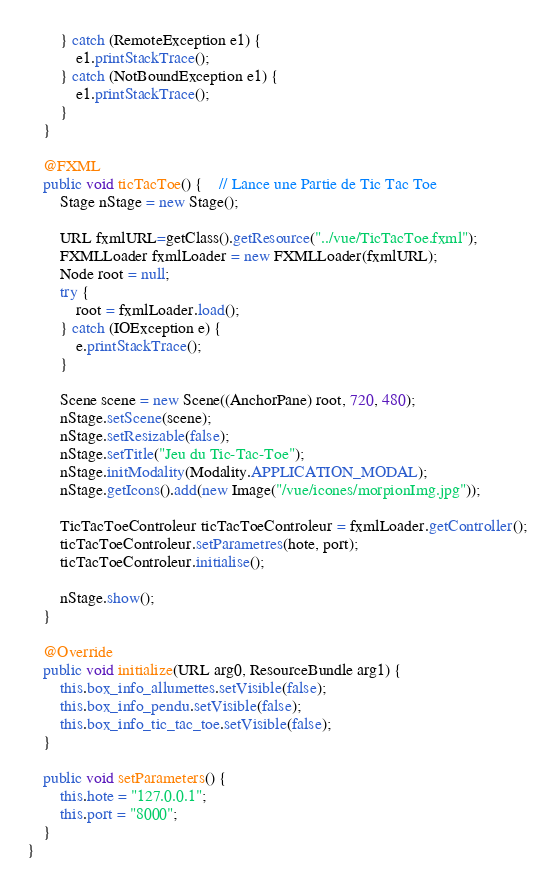<code> <loc_0><loc_0><loc_500><loc_500><_Java_>		} catch (RemoteException e1) {
			e1.printStackTrace();
		} catch (NotBoundException e1) {
			e1.printStackTrace();
		}
	}
	
	@FXML
	public void ticTacToe() {	// Lance une Partie de Tic Tac Toe
		Stage nStage = new Stage();
		
		URL fxmlURL=getClass().getResource("../vue/TicTacToe.fxml");
		FXMLLoader fxmlLoader = new FXMLLoader(fxmlURL);
		Node root = null;
		try {
			root = fxmlLoader.load();
		} catch (IOException e) {
			e.printStackTrace();
		}
	
		Scene scene = new Scene((AnchorPane) root, 720, 480);
		nStage.setScene(scene);
		nStage.setResizable(false);
		nStage.setTitle("Jeu du Tic-Tac-Toe");
		nStage.initModality(Modality.APPLICATION_MODAL);
		nStage.getIcons().add(new Image("/vue/icones/morpionImg.jpg"));
		
		TicTacToeControleur ticTacToeControleur = fxmlLoader.getController();
		ticTacToeControleur.setParametres(hote, port);
		ticTacToeControleur.initialise();
		
		nStage.show();
	}

	@Override
	public void initialize(URL arg0, ResourceBundle arg1) {
		this.box_info_allumettes.setVisible(false);
		this.box_info_pendu.setVisible(false);
		this.box_info_tic_tac_toe.setVisible(false);
	}
	
	public void setParameters() {
		this.hote = "127.0.0.1";
		this.port = "8000";
	}
}
</code> 